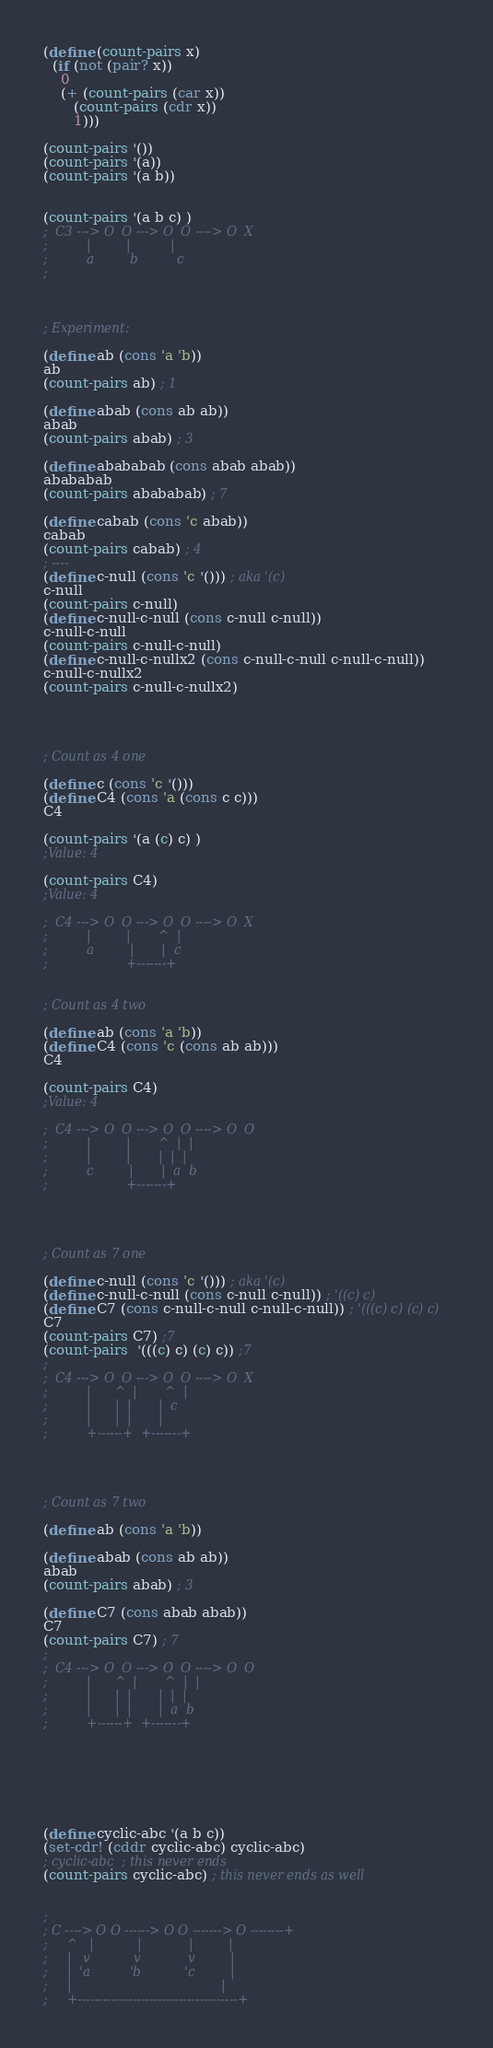<code> <loc_0><loc_0><loc_500><loc_500><_Scheme_>(define (count-pairs x)
  (if (not (pair? x))
    0
    (+ (count-pairs (car x))
       (count-pairs (cdr x))
       1)))

(count-pairs '())
(count-pairs '(a))
(count-pairs '(a b))


(count-pairs '(a b c) )
;  C3 ---> O  O ---> O  O ----> O  X
;          |         |          |
;          a         b          c
;



; Experiment:

(define ab (cons 'a 'b))
ab
(count-pairs ab) ; 1

(define abab (cons ab ab))
abab
(count-pairs abab) ; 3

(define abababab (cons abab abab))
abababab
(count-pairs abababab) ; 7

(define cabab (cons 'c abab))
cabab
(count-pairs cabab) ; 4
; ----
(define c-null (cons 'c '())) ; aka '(c)
c-null
(count-pairs c-null)
(define c-null-c-null (cons c-null c-null))
c-null-c-null
(count-pairs c-null-c-null)
(define c-null-c-nullx2 (cons c-null-c-null c-null-c-null))
c-null-c-nullx2
(count-pairs c-null-c-nullx2)




; Count as 4 one

(define c (cons 'c '()))
(define C4 (cons 'a (cons c c)))
C4

(count-pairs '(a (c) c) )
;Value: 4

(count-pairs C4)
;Value: 4

;  C4 ---> O  O ---> O  O ----> O  X
;          |         |       ^  |
;          a         |       |  c
;                    +-------+


; Count as 4 two

(define ab (cons 'a 'b))
(define C4 (cons 'c (cons ab ab)))
C4

(count-pairs C4)
;Value: 4

;  C4 ---> O  O ---> O  O ----> O  O
;          |         |       ^  |  |
;          |         |       |  |  |
;          c         |       |  a  b
;                    +-------+




; Count as 7 one

(define c-null (cons 'c '())) ; aka '(c)
(define c-null-c-null (cons c-null c-null)) ; '((c) c)
(define C7 (cons c-null-c-null c-null-c-null)) ; '(((c) c) (c) c)
C7
(count-pairs C7) ;7
(count-pairs  '(((c) c) (c) c)) ;7
;
;  C4 ---> O  O ---> O  O ----> O  X
;          |      ^  |       ^  |
;          |      |  |       |  c
;          |      |  |       |
;          +------+  +-------+




; Count as 7 two

(define ab (cons 'a 'b))

(define abab (cons ab ab))
abab
(count-pairs abab) ; 3

(define C7 (cons abab abab))
C7
(count-pairs C7) ; 7
;
;  C4 ---> O  O ---> O  O ----> O  O
;          |      ^  |       ^  |  |
;          |      |  |       |  |  |
;          |      |  |       |  a  b
;          +------+  +-------+







(define cyclic-abc '(a b c))
(set-cdr! (cddr cyclic-abc) cyclic-abc)
; cyclic-abc  ; this never ends
(count-pairs cyclic-abc) ; this never ends as well


;
; C ----> O O ------> O O -------> O --------+
;     ^   |           |            |         |
;     |   v           v            v         |
;     |  'a          'b           'c         |
;     |                                      |
;     +--------------------------------------+


</code> 